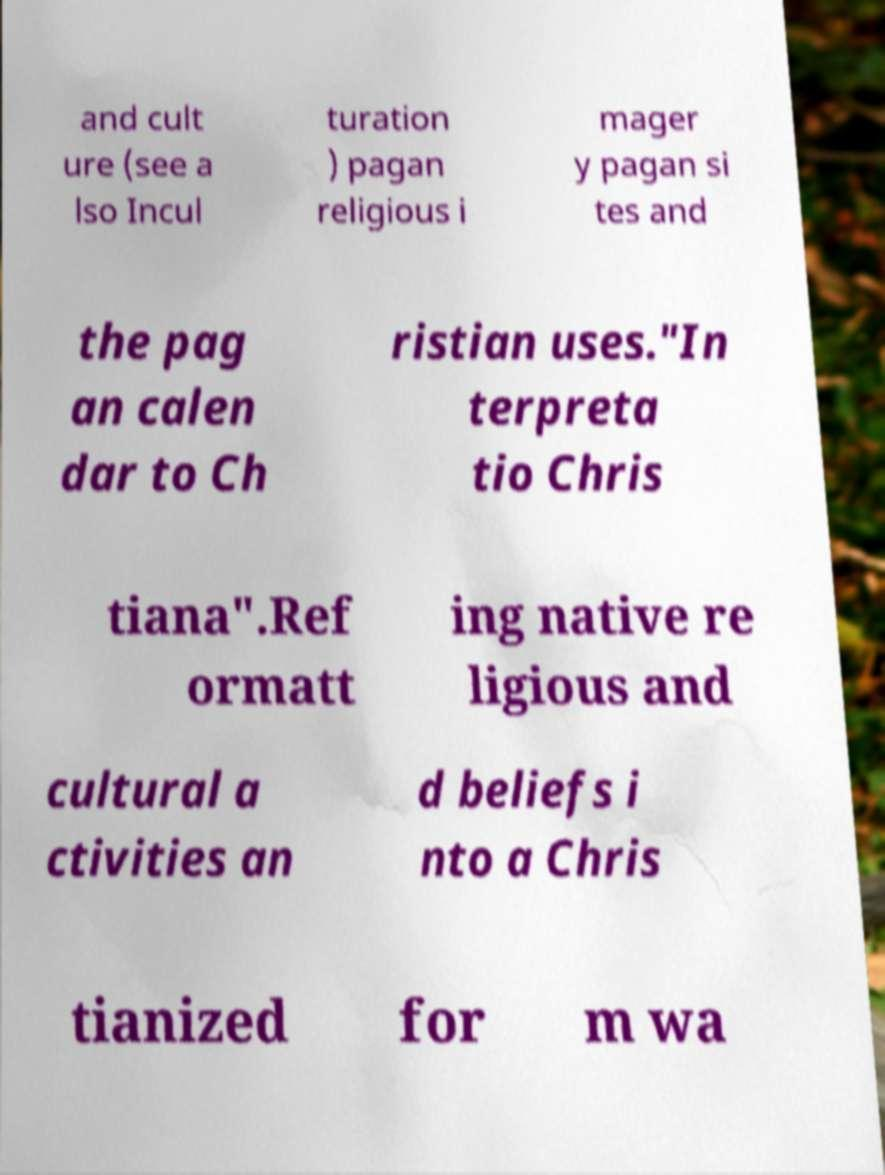Please identify and transcribe the text found in this image. and cult ure (see a lso Incul turation ) pagan religious i mager y pagan si tes and the pag an calen dar to Ch ristian uses."In terpreta tio Chris tiana".Ref ormatt ing native re ligious and cultural a ctivities an d beliefs i nto a Chris tianized for m wa 